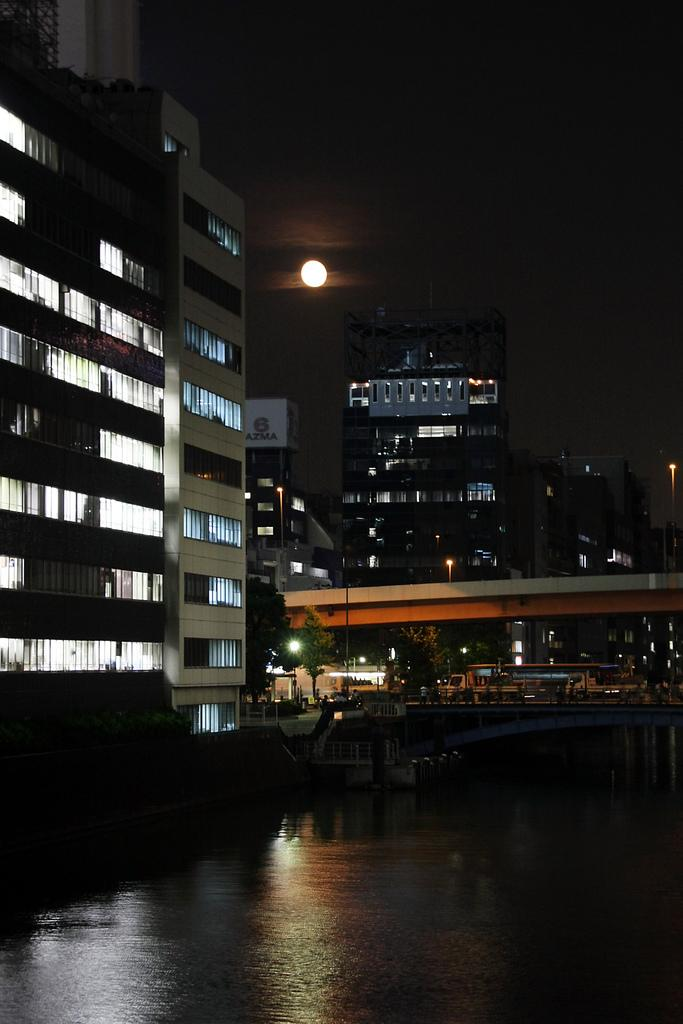What is the main element present in the image? There is water in the image. What structure can be seen crossing over the water? There is a bridge in the image. What else can be seen on the road in the image? There are persons on the road in the image. What type of transportation is visible in the image? There are vehicles in the image. What type of man-made structures are present in the image? There are buildings in the image. What type of illumination can be seen in the image? There are lights in the image. What is the condition of the sky in the background of the image? The sky is dark in the background of the image. What celestial body is visible in the background of the image? The moon is visible in the background of the image. How many toads are hopping on the bridge in the image? There are no toads present in the image. What type of mass is being transported by the vehicles in the image? The image does not provide information about the type of mass being transported by the vehicles. 